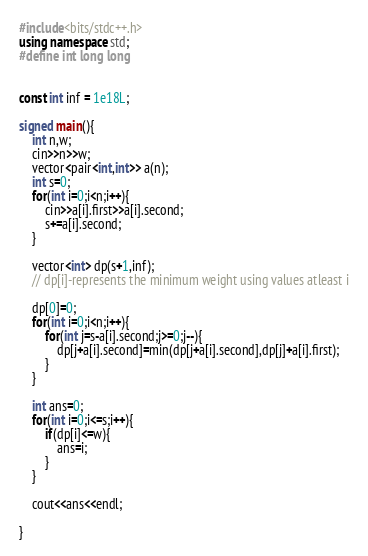<code> <loc_0><loc_0><loc_500><loc_500><_C++_>#include<bits/stdc++.h>
using namespace std;
#define int long long 
 
 
const int inf = 1e18L;
 
signed main(){
	int n,w;
	cin>>n>>w;
	vector<pair<int,int>> a(n);
	int s=0;
	for(int i=0;i<n;i++){
		cin>>a[i].first>>a[i].second;
		s+=a[i].second;
	}
 
	vector<int> dp(s+1,inf);
	// dp[i]-represents the minimum weight using values atleast i
	
	dp[0]=0;
	for(int i=0;i<n;i++){
		for(int j=s-a[i].second;j>=0;j--){
			dp[j+a[i].second]=min(dp[j+a[i].second],dp[j]+a[i].first);
		}
	}
 
	int ans=0;
	for(int i=0;i<=s;i++){
		if(dp[i]<=w){
			ans=i;
		}
	}
 
	cout<<ans<<endl;
 
}
</code> 